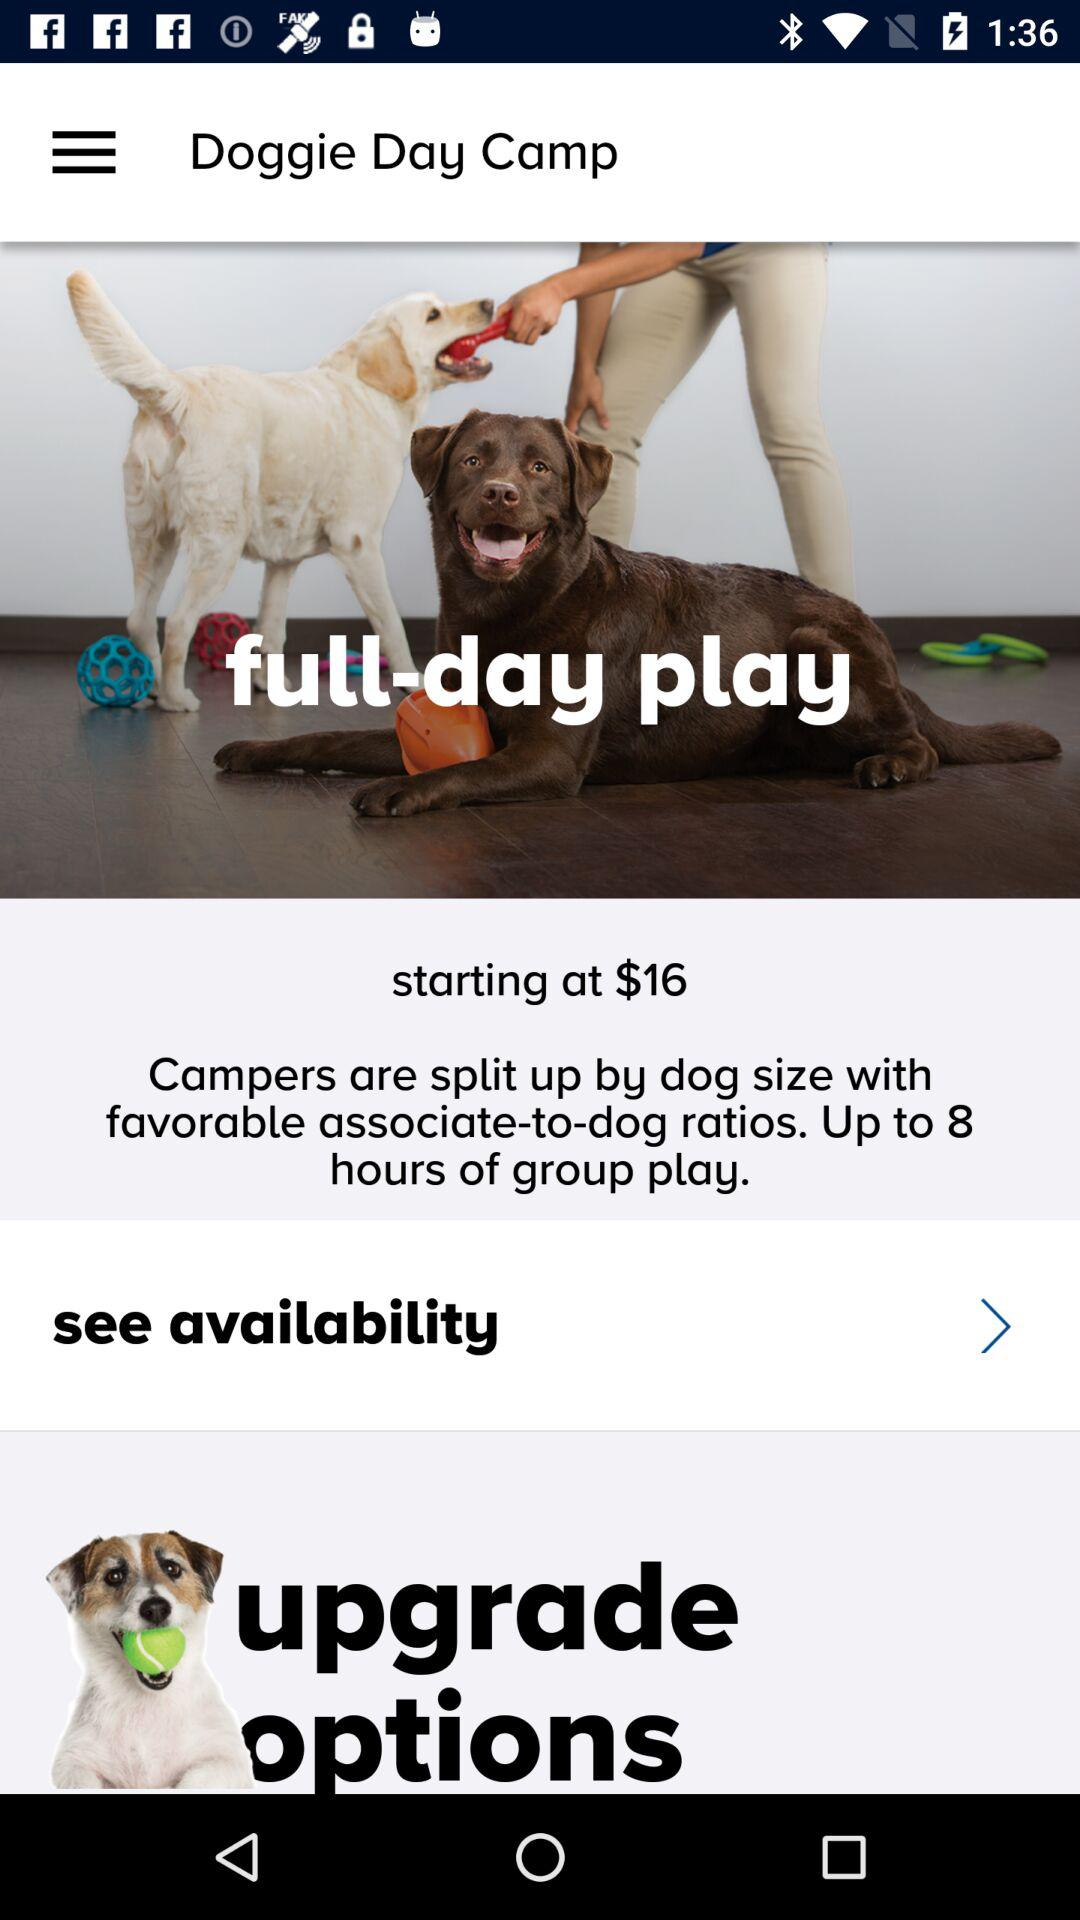How much is a half-day play?
When the provided information is insufficient, respond with <no answer>. <no answer> 